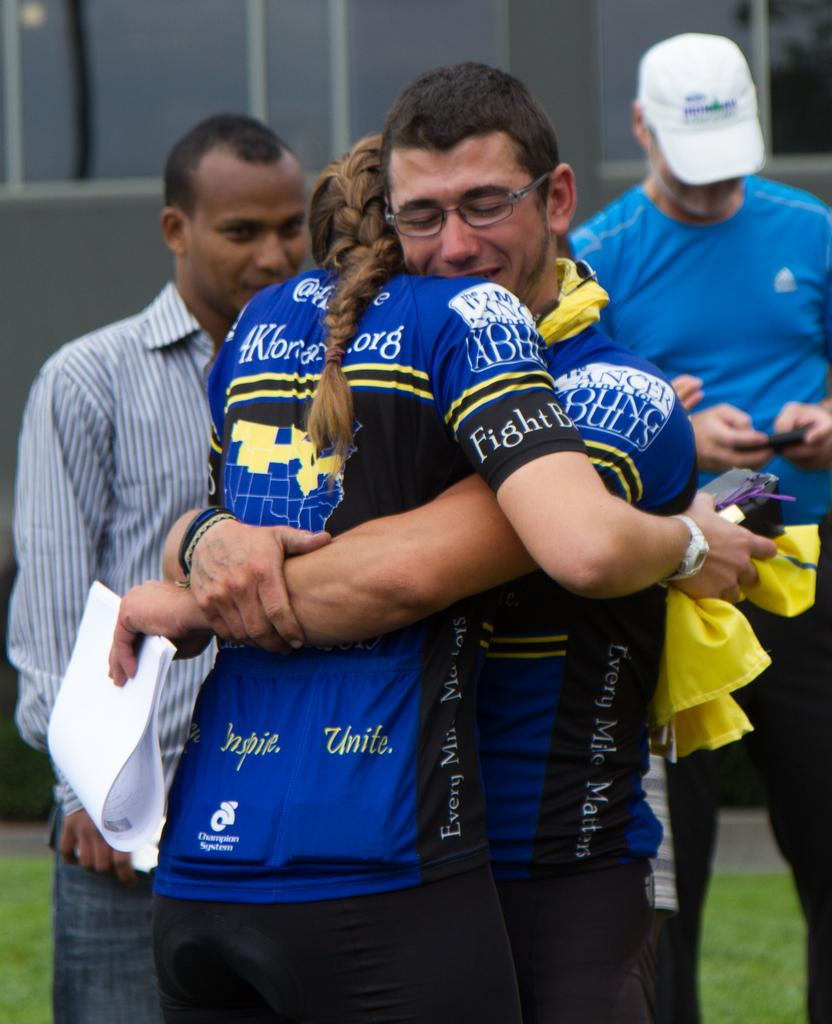Provide a one-sentence caption for the provided image. A man and woman in matching shirts that includes the words every mile matters hug. 